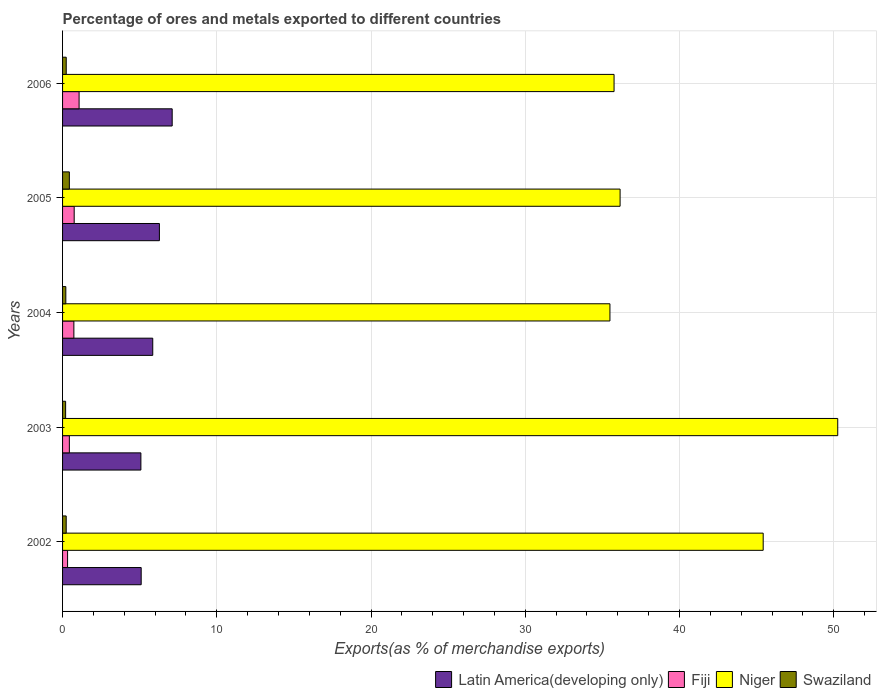How many different coloured bars are there?
Give a very brief answer. 4. Are the number of bars on each tick of the Y-axis equal?
Offer a very short reply. Yes. How many bars are there on the 4th tick from the top?
Provide a succinct answer. 4. How many bars are there on the 3rd tick from the bottom?
Keep it short and to the point. 4. In how many cases, is the number of bars for a given year not equal to the number of legend labels?
Offer a terse response. 0. What is the percentage of exports to different countries in Fiji in 2002?
Keep it short and to the point. 0.33. Across all years, what is the maximum percentage of exports to different countries in Swaziland?
Keep it short and to the point. 0.44. Across all years, what is the minimum percentage of exports to different countries in Latin America(developing only)?
Make the answer very short. 5.08. In which year was the percentage of exports to different countries in Fiji maximum?
Keep it short and to the point. 2006. What is the total percentage of exports to different countries in Latin America(developing only) in the graph?
Ensure brevity in your answer.  29.41. What is the difference between the percentage of exports to different countries in Latin America(developing only) in 2004 and that in 2006?
Provide a succinct answer. -1.26. What is the difference between the percentage of exports to different countries in Fiji in 2006 and the percentage of exports to different countries in Niger in 2002?
Offer a terse response. -44.35. What is the average percentage of exports to different countries in Latin America(developing only) per year?
Keep it short and to the point. 5.88. In the year 2006, what is the difference between the percentage of exports to different countries in Latin America(developing only) and percentage of exports to different countries in Fiji?
Offer a terse response. 6.04. What is the ratio of the percentage of exports to different countries in Latin America(developing only) in 2004 to that in 2005?
Your answer should be very brief. 0.93. What is the difference between the highest and the second highest percentage of exports to different countries in Fiji?
Offer a terse response. 0.32. What is the difference between the highest and the lowest percentage of exports to different countries in Latin America(developing only)?
Give a very brief answer. 2.03. In how many years, is the percentage of exports to different countries in Niger greater than the average percentage of exports to different countries in Niger taken over all years?
Provide a short and direct response. 2. Is it the case that in every year, the sum of the percentage of exports to different countries in Latin America(developing only) and percentage of exports to different countries in Niger is greater than the sum of percentage of exports to different countries in Fiji and percentage of exports to different countries in Swaziland?
Your response must be concise. Yes. What does the 3rd bar from the top in 2002 represents?
Offer a very short reply. Fiji. What does the 2nd bar from the bottom in 2004 represents?
Your answer should be compact. Fiji. Is it the case that in every year, the sum of the percentage of exports to different countries in Swaziland and percentage of exports to different countries in Fiji is greater than the percentage of exports to different countries in Niger?
Keep it short and to the point. No. How many bars are there?
Keep it short and to the point. 20. Are all the bars in the graph horizontal?
Provide a succinct answer. Yes. How many years are there in the graph?
Your answer should be compact. 5. Are the values on the major ticks of X-axis written in scientific E-notation?
Ensure brevity in your answer.  No. How are the legend labels stacked?
Give a very brief answer. Horizontal. What is the title of the graph?
Offer a very short reply. Percentage of ores and metals exported to different countries. Does "Low income" appear as one of the legend labels in the graph?
Provide a succinct answer. No. What is the label or title of the X-axis?
Your answer should be compact. Exports(as % of merchandise exports). What is the label or title of the Y-axis?
Make the answer very short. Years. What is the Exports(as % of merchandise exports) in Latin America(developing only) in 2002?
Your response must be concise. 5.1. What is the Exports(as % of merchandise exports) of Fiji in 2002?
Your answer should be compact. 0.33. What is the Exports(as % of merchandise exports) in Niger in 2002?
Provide a succinct answer. 45.42. What is the Exports(as % of merchandise exports) in Swaziland in 2002?
Your response must be concise. 0.24. What is the Exports(as % of merchandise exports) of Latin America(developing only) in 2003?
Offer a very short reply. 5.08. What is the Exports(as % of merchandise exports) in Fiji in 2003?
Your response must be concise. 0.44. What is the Exports(as % of merchandise exports) in Niger in 2003?
Provide a short and direct response. 50.26. What is the Exports(as % of merchandise exports) in Swaziland in 2003?
Provide a short and direct response. 0.2. What is the Exports(as % of merchandise exports) in Latin America(developing only) in 2004?
Make the answer very short. 5.85. What is the Exports(as % of merchandise exports) of Fiji in 2004?
Give a very brief answer. 0.73. What is the Exports(as % of merchandise exports) in Niger in 2004?
Your answer should be compact. 35.49. What is the Exports(as % of merchandise exports) in Swaziland in 2004?
Your answer should be compact. 0.21. What is the Exports(as % of merchandise exports) in Latin America(developing only) in 2005?
Provide a short and direct response. 6.28. What is the Exports(as % of merchandise exports) of Fiji in 2005?
Keep it short and to the point. 0.75. What is the Exports(as % of merchandise exports) of Niger in 2005?
Offer a terse response. 36.15. What is the Exports(as % of merchandise exports) in Swaziland in 2005?
Your answer should be compact. 0.44. What is the Exports(as % of merchandise exports) in Latin America(developing only) in 2006?
Provide a succinct answer. 7.11. What is the Exports(as % of merchandise exports) in Fiji in 2006?
Your response must be concise. 1.07. What is the Exports(as % of merchandise exports) in Niger in 2006?
Make the answer very short. 35.76. What is the Exports(as % of merchandise exports) of Swaziland in 2006?
Make the answer very short. 0.24. Across all years, what is the maximum Exports(as % of merchandise exports) in Latin America(developing only)?
Give a very brief answer. 7.11. Across all years, what is the maximum Exports(as % of merchandise exports) in Fiji?
Keep it short and to the point. 1.07. Across all years, what is the maximum Exports(as % of merchandise exports) of Niger?
Make the answer very short. 50.26. Across all years, what is the maximum Exports(as % of merchandise exports) of Swaziland?
Offer a very short reply. 0.44. Across all years, what is the minimum Exports(as % of merchandise exports) in Latin America(developing only)?
Keep it short and to the point. 5.08. Across all years, what is the minimum Exports(as % of merchandise exports) in Fiji?
Your response must be concise. 0.33. Across all years, what is the minimum Exports(as % of merchandise exports) in Niger?
Give a very brief answer. 35.49. Across all years, what is the minimum Exports(as % of merchandise exports) of Swaziland?
Your answer should be very brief. 0.2. What is the total Exports(as % of merchandise exports) of Latin America(developing only) in the graph?
Make the answer very short. 29.41. What is the total Exports(as % of merchandise exports) in Fiji in the graph?
Offer a terse response. 3.32. What is the total Exports(as % of merchandise exports) of Niger in the graph?
Provide a succinct answer. 203.07. What is the total Exports(as % of merchandise exports) in Swaziland in the graph?
Provide a short and direct response. 1.33. What is the difference between the Exports(as % of merchandise exports) in Latin America(developing only) in 2002 and that in 2003?
Make the answer very short. 0.02. What is the difference between the Exports(as % of merchandise exports) in Fiji in 2002 and that in 2003?
Offer a very short reply. -0.11. What is the difference between the Exports(as % of merchandise exports) of Niger in 2002 and that in 2003?
Give a very brief answer. -4.83. What is the difference between the Exports(as % of merchandise exports) of Swaziland in 2002 and that in 2003?
Offer a terse response. 0.04. What is the difference between the Exports(as % of merchandise exports) in Latin America(developing only) in 2002 and that in 2004?
Provide a short and direct response. -0.75. What is the difference between the Exports(as % of merchandise exports) in Fiji in 2002 and that in 2004?
Offer a very short reply. -0.41. What is the difference between the Exports(as % of merchandise exports) of Niger in 2002 and that in 2004?
Ensure brevity in your answer.  9.94. What is the difference between the Exports(as % of merchandise exports) in Swaziland in 2002 and that in 2004?
Offer a very short reply. 0.02. What is the difference between the Exports(as % of merchandise exports) in Latin America(developing only) in 2002 and that in 2005?
Offer a terse response. -1.18. What is the difference between the Exports(as % of merchandise exports) of Fiji in 2002 and that in 2005?
Your answer should be very brief. -0.43. What is the difference between the Exports(as % of merchandise exports) of Niger in 2002 and that in 2005?
Provide a succinct answer. 9.28. What is the difference between the Exports(as % of merchandise exports) of Swaziland in 2002 and that in 2005?
Provide a succinct answer. -0.21. What is the difference between the Exports(as % of merchandise exports) of Latin America(developing only) in 2002 and that in 2006?
Provide a succinct answer. -2.01. What is the difference between the Exports(as % of merchandise exports) of Fiji in 2002 and that in 2006?
Provide a short and direct response. -0.75. What is the difference between the Exports(as % of merchandise exports) in Niger in 2002 and that in 2006?
Ensure brevity in your answer.  9.67. What is the difference between the Exports(as % of merchandise exports) of Swaziland in 2002 and that in 2006?
Your answer should be compact. -0. What is the difference between the Exports(as % of merchandise exports) in Latin America(developing only) in 2003 and that in 2004?
Ensure brevity in your answer.  -0.77. What is the difference between the Exports(as % of merchandise exports) of Fiji in 2003 and that in 2004?
Give a very brief answer. -0.29. What is the difference between the Exports(as % of merchandise exports) in Niger in 2003 and that in 2004?
Provide a short and direct response. 14.77. What is the difference between the Exports(as % of merchandise exports) of Swaziland in 2003 and that in 2004?
Offer a very short reply. -0.01. What is the difference between the Exports(as % of merchandise exports) in Latin America(developing only) in 2003 and that in 2005?
Your response must be concise. -1.2. What is the difference between the Exports(as % of merchandise exports) in Fiji in 2003 and that in 2005?
Ensure brevity in your answer.  -0.31. What is the difference between the Exports(as % of merchandise exports) of Niger in 2003 and that in 2005?
Make the answer very short. 14.11. What is the difference between the Exports(as % of merchandise exports) of Swaziland in 2003 and that in 2005?
Offer a terse response. -0.24. What is the difference between the Exports(as % of merchandise exports) of Latin America(developing only) in 2003 and that in 2006?
Make the answer very short. -2.03. What is the difference between the Exports(as % of merchandise exports) in Fiji in 2003 and that in 2006?
Your answer should be compact. -0.63. What is the difference between the Exports(as % of merchandise exports) of Niger in 2003 and that in 2006?
Offer a terse response. 14.5. What is the difference between the Exports(as % of merchandise exports) of Swaziland in 2003 and that in 2006?
Your answer should be compact. -0.04. What is the difference between the Exports(as % of merchandise exports) in Latin America(developing only) in 2004 and that in 2005?
Your response must be concise. -0.43. What is the difference between the Exports(as % of merchandise exports) of Fiji in 2004 and that in 2005?
Provide a succinct answer. -0.02. What is the difference between the Exports(as % of merchandise exports) of Niger in 2004 and that in 2005?
Provide a short and direct response. -0.66. What is the difference between the Exports(as % of merchandise exports) of Swaziland in 2004 and that in 2005?
Ensure brevity in your answer.  -0.23. What is the difference between the Exports(as % of merchandise exports) in Latin America(developing only) in 2004 and that in 2006?
Provide a succinct answer. -1.26. What is the difference between the Exports(as % of merchandise exports) in Fiji in 2004 and that in 2006?
Give a very brief answer. -0.34. What is the difference between the Exports(as % of merchandise exports) of Niger in 2004 and that in 2006?
Give a very brief answer. -0.27. What is the difference between the Exports(as % of merchandise exports) of Swaziland in 2004 and that in 2006?
Give a very brief answer. -0.03. What is the difference between the Exports(as % of merchandise exports) in Latin America(developing only) in 2005 and that in 2006?
Provide a short and direct response. -0.83. What is the difference between the Exports(as % of merchandise exports) in Fiji in 2005 and that in 2006?
Provide a succinct answer. -0.32. What is the difference between the Exports(as % of merchandise exports) of Niger in 2005 and that in 2006?
Your answer should be very brief. 0.39. What is the difference between the Exports(as % of merchandise exports) of Swaziland in 2005 and that in 2006?
Provide a succinct answer. 0.2. What is the difference between the Exports(as % of merchandise exports) in Latin America(developing only) in 2002 and the Exports(as % of merchandise exports) in Fiji in 2003?
Make the answer very short. 4.66. What is the difference between the Exports(as % of merchandise exports) of Latin America(developing only) in 2002 and the Exports(as % of merchandise exports) of Niger in 2003?
Offer a very short reply. -45.16. What is the difference between the Exports(as % of merchandise exports) in Latin America(developing only) in 2002 and the Exports(as % of merchandise exports) in Swaziland in 2003?
Offer a terse response. 4.9. What is the difference between the Exports(as % of merchandise exports) in Fiji in 2002 and the Exports(as % of merchandise exports) in Niger in 2003?
Give a very brief answer. -49.93. What is the difference between the Exports(as % of merchandise exports) of Fiji in 2002 and the Exports(as % of merchandise exports) of Swaziland in 2003?
Give a very brief answer. 0.13. What is the difference between the Exports(as % of merchandise exports) of Niger in 2002 and the Exports(as % of merchandise exports) of Swaziland in 2003?
Give a very brief answer. 45.23. What is the difference between the Exports(as % of merchandise exports) of Latin America(developing only) in 2002 and the Exports(as % of merchandise exports) of Fiji in 2004?
Provide a short and direct response. 4.36. What is the difference between the Exports(as % of merchandise exports) of Latin America(developing only) in 2002 and the Exports(as % of merchandise exports) of Niger in 2004?
Offer a very short reply. -30.39. What is the difference between the Exports(as % of merchandise exports) in Latin America(developing only) in 2002 and the Exports(as % of merchandise exports) in Swaziland in 2004?
Provide a succinct answer. 4.89. What is the difference between the Exports(as % of merchandise exports) of Fiji in 2002 and the Exports(as % of merchandise exports) of Niger in 2004?
Offer a terse response. -35.16. What is the difference between the Exports(as % of merchandise exports) of Fiji in 2002 and the Exports(as % of merchandise exports) of Swaziland in 2004?
Your answer should be very brief. 0.11. What is the difference between the Exports(as % of merchandise exports) in Niger in 2002 and the Exports(as % of merchandise exports) in Swaziland in 2004?
Provide a succinct answer. 45.21. What is the difference between the Exports(as % of merchandise exports) in Latin America(developing only) in 2002 and the Exports(as % of merchandise exports) in Fiji in 2005?
Your answer should be compact. 4.34. What is the difference between the Exports(as % of merchandise exports) in Latin America(developing only) in 2002 and the Exports(as % of merchandise exports) in Niger in 2005?
Your answer should be very brief. -31.05. What is the difference between the Exports(as % of merchandise exports) of Latin America(developing only) in 2002 and the Exports(as % of merchandise exports) of Swaziland in 2005?
Keep it short and to the point. 4.66. What is the difference between the Exports(as % of merchandise exports) in Fiji in 2002 and the Exports(as % of merchandise exports) in Niger in 2005?
Provide a short and direct response. -35.82. What is the difference between the Exports(as % of merchandise exports) of Fiji in 2002 and the Exports(as % of merchandise exports) of Swaziland in 2005?
Keep it short and to the point. -0.12. What is the difference between the Exports(as % of merchandise exports) of Niger in 2002 and the Exports(as % of merchandise exports) of Swaziland in 2005?
Provide a succinct answer. 44.98. What is the difference between the Exports(as % of merchandise exports) of Latin America(developing only) in 2002 and the Exports(as % of merchandise exports) of Fiji in 2006?
Your response must be concise. 4.03. What is the difference between the Exports(as % of merchandise exports) in Latin America(developing only) in 2002 and the Exports(as % of merchandise exports) in Niger in 2006?
Make the answer very short. -30.66. What is the difference between the Exports(as % of merchandise exports) in Latin America(developing only) in 2002 and the Exports(as % of merchandise exports) in Swaziland in 2006?
Offer a very short reply. 4.86. What is the difference between the Exports(as % of merchandise exports) of Fiji in 2002 and the Exports(as % of merchandise exports) of Niger in 2006?
Keep it short and to the point. -35.43. What is the difference between the Exports(as % of merchandise exports) of Fiji in 2002 and the Exports(as % of merchandise exports) of Swaziland in 2006?
Give a very brief answer. 0.09. What is the difference between the Exports(as % of merchandise exports) of Niger in 2002 and the Exports(as % of merchandise exports) of Swaziland in 2006?
Offer a terse response. 45.19. What is the difference between the Exports(as % of merchandise exports) of Latin America(developing only) in 2003 and the Exports(as % of merchandise exports) of Fiji in 2004?
Give a very brief answer. 4.35. What is the difference between the Exports(as % of merchandise exports) of Latin America(developing only) in 2003 and the Exports(as % of merchandise exports) of Niger in 2004?
Your answer should be compact. -30.41. What is the difference between the Exports(as % of merchandise exports) of Latin America(developing only) in 2003 and the Exports(as % of merchandise exports) of Swaziland in 2004?
Offer a terse response. 4.87. What is the difference between the Exports(as % of merchandise exports) of Fiji in 2003 and the Exports(as % of merchandise exports) of Niger in 2004?
Your answer should be very brief. -35.05. What is the difference between the Exports(as % of merchandise exports) in Fiji in 2003 and the Exports(as % of merchandise exports) in Swaziland in 2004?
Provide a short and direct response. 0.23. What is the difference between the Exports(as % of merchandise exports) in Niger in 2003 and the Exports(as % of merchandise exports) in Swaziland in 2004?
Ensure brevity in your answer.  50.05. What is the difference between the Exports(as % of merchandise exports) in Latin America(developing only) in 2003 and the Exports(as % of merchandise exports) in Fiji in 2005?
Offer a terse response. 4.32. What is the difference between the Exports(as % of merchandise exports) in Latin America(developing only) in 2003 and the Exports(as % of merchandise exports) in Niger in 2005?
Provide a succinct answer. -31.07. What is the difference between the Exports(as % of merchandise exports) in Latin America(developing only) in 2003 and the Exports(as % of merchandise exports) in Swaziland in 2005?
Offer a terse response. 4.64. What is the difference between the Exports(as % of merchandise exports) of Fiji in 2003 and the Exports(as % of merchandise exports) of Niger in 2005?
Your response must be concise. -35.71. What is the difference between the Exports(as % of merchandise exports) in Fiji in 2003 and the Exports(as % of merchandise exports) in Swaziland in 2005?
Ensure brevity in your answer.  -0. What is the difference between the Exports(as % of merchandise exports) in Niger in 2003 and the Exports(as % of merchandise exports) in Swaziland in 2005?
Your answer should be compact. 49.82. What is the difference between the Exports(as % of merchandise exports) of Latin America(developing only) in 2003 and the Exports(as % of merchandise exports) of Fiji in 2006?
Your response must be concise. 4.01. What is the difference between the Exports(as % of merchandise exports) of Latin America(developing only) in 2003 and the Exports(as % of merchandise exports) of Niger in 2006?
Offer a terse response. -30.68. What is the difference between the Exports(as % of merchandise exports) of Latin America(developing only) in 2003 and the Exports(as % of merchandise exports) of Swaziland in 2006?
Keep it short and to the point. 4.84. What is the difference between the Exports(as % of merchandise exports) of Fiji in 2003 and the Exports(as % of merchandise exports) of Niger in 2006?
Your answer should be very brief. -35.32. What is the difference between the Exports(as % of merchandise exports) of Fiji in 2003 and the Exports(as % of merchandise exports) of Swaziland in 2006?
Your answer should be compact. 0.2. What is the difference between the Exports(as % of merchandise exports) of Niger in 2003 and the Exports(as % of merchandise exports) of Swaziland in 2006?
Your answer should be very brief. 50.02. What is the difference between the Exports(as % of merchandise exports) in Latin America(developing only) in 2004 and the Exports(as % of merchandise exports) in Fiji in 2005?
Offer a very short reply. 5.09. What is the difference between the Exports(as % of merchandise exports) of Latin America(developing only) in 2004 and the Exports(as % of merchandise exports) of Niger in 2005?
Make the answer very short. -30.3. What is the difference between the Exports(as % of merchandise exports) in Latin America(developing only) in 2004 and the Exports(as % of merchandise exports) in Swaziland in 2005?
Ensure brevity in your answer.  5.41. What is the difference between the Exports(as % of merchandise exports) in Fiji in 2004 and the Exports(as % of merchandise exports) in Niger in 2005?
Your answer should be compact. -35.41. What is the difference between the Exports(as % of merchandise exports) in Fiji in 2004 and the Exports(as % of merchandise exports) in Swaziland in 2005?
Your response must be concise. 0.29. What is the difference between the Exports(as % of merchandise exports) in Niger in 2004 and the Exports(as % of merchandise exports) in Swaziland in 2005?
Your answer should be compact. 35.05. What is the difference between the Exports(as % of merchandise exports) in Latin America(developing only) in 2004 and the Exports(as % of merchandise exports) in Fiji in 2006?
Keep it short and to the point. 4.78. What is the difference between the Exports(as % of merchandise exports) of Latin America(developing only) in 2004 and the Exports(as % of merchandise exports) of Niger in 2006?
Give a very brief answer. -29.91. What is the difference between the Exports(as % of merchandise exports) of Latin America(developing only) in 2004 and the Exports(as % of merchandise exports) of Swaziland in 2006?
Provide a succinct answer. 5.61. What is the difference between the Exports(as % of merchandise exports) in Fiji in 2004 and the Exports(as % of merchandise exports) in Niger in 2006?
Make the answer very short. -35.02. What is the difference between the Exports(as % of merchandise exports) of Fiji in 2004 and the Exports(as % of merchandise exports) of Swaziland in 2006?
Offer a very short reply. 0.5. What is the difference between the Exports(as % of merchandise exports) in Niger in 2004 and the Exports(as % of merchandise exports) in Swaziland in 2006?
Keep it short and to the point. 35.25. What is the difference between the Exports(as % of merchandise exports) in Latin America(developing only) in 2005 and the Exports(as % of merchandise exports) in Fiji in 2006?
Your answer should be compact. 5.21. What is the difference between the Exports(as % of merchandise exports) in Latin America(developing only) in 2005 and the Exports(as % of merchandise exports) in Niger in 2006?
Give a very brief answer. -29.48. What is the difference between the Exports(as % of merchandise exports) in Latin America(developing only) in 2005 and the Exports(as % of merchandise exports) in Swaziland in 2006?
Provide a short and direct response. 6.04. What is the difference between the Exports(as % of merchandise exports) of Fiji in 2005 and the Exports(as % of merchandise exports) of Niger in 2006?
Your response must be concise. -35. What is the difference between the Exports(as % of merchandise exports) of Fiji in 2005 and the Exports(as % of merchandise exports) of Swaziland in 2006?
Your answer should be compact. 0.52. What is the difference between the Exports(as % of merchandise exports) in Niger in 2005 and the Exports(as % of merchandise exports) in Swaziland in 2006?
Provide a succinct answer. 35.91. What is the average Exports(as % of merchandise exports) of Latin America(developing only) per year?
Offer a terse response. 5.88. What is the average Exports(as % of merchandise exports) of Fiji per year?
Give a very brief answer. 0.66. What is the average Exports(as % of merchandise exports) in Niger per year?
Offer a very short reply. 40.61. What is the average Exports(as % of merchandise exports) in Swaziland per year?
Your answer should be compact. 0.27. In the year 2002, what is the difference between the Exports(as % of merchandise exports) in Latin America(developing only) and Exports(as % of merchandise exports) in Fiji?
Your answer should be very brief. 4.77. In the year 2002, what is the difference between the Exports(as % of merchandise exports) in Latin America(developing only) and Exports(as % of merchandise exports) in Niger?
Keep it short and to the point. -40.33. In the year 2002, what is the difference between the Exports(as % of merchandise exports) of Latin America(developing only) and Exports(as % of merchandise exports) of Swaziland?
Your response must be concise. 4.86. In the year 2002, what is the difference between the Exports(as % of merchandise exports) of Fiji and Exports(as % of merchandise exports) of Niger?
Give a very brief answer. -45.1. In the year 2002, what is the difference between the Exports(as % of merchandise exports) of Fiji and Exports(as % of merchandise exports) of Swaziland?
Provide a short and direct response. 0.09. In the year 2002, what is the difference between the Exports(as % of merchandise exports) in Niger and Exports(as % of merchandise exports) in Swaziland?
Provide a succinct answer. 45.19. In the year 2003, what is the difference between the Exports(as % of merchandise exports) in Latin America(developing only) and Exports(as % of merchandise exports) in Fiji?
Make the answer very short. 4.64. In the year 2003, what is the difference between the Exports(as % of merchandise exports) in Latin America(developing only) and Exports(as % of merchandise exports) in Niger?
Make the answer very short. -45.18. In the year 2003, what is the difference between the Exports(as % of merchandise exports) in Latin America(developing only) and Exports(as % of merchandise exports) in Swaziland?
Provide a short and direct response. 4.88. In the year 2003, what is the difference between the Exports(as % of merchandise exports) in Fiji and Exports(as % of merchandise exports) in Niger?
Offer a very short reply. -49.82. In the year 2003, what is the difference between the Exports(as % of merchandise exports) of Fiji and Exports(as % of merchandise exports) of Swaziland?
Your answer should be compact. 0.24. In the year 2003, what is the difference between the Exports(as % of merchandise exports) of Niger and Exports(as % of merchandise exports) of Swaziland?
Give a very brief answer. 50.06. In the year 2004, what is the difference between the Exports(as % of merchandise exports) in Latin America(developing only) and Exports(as % of merchandise exports) in Fiji?
Your response must be concise. 5.11. In the year 2004, what is the difference between the Exports(as % of merchandise exports) in Latin America(developing only) and Exports(as % of merchandise exports) in Niger?
Your answer should be compact. -29.64. In the year 2004, what is the difference between the Exports(as % of merchandise exports) of Latin America(developing only) and Exports(as % of merchandise exports) of Swaziland?
Your answer should be very brief. 5.63. In the year 2004, what is the difference between the Exports(as % of merchandise exports) of Fiji and Exports(as % of merchandise exports) of Niger?
Keep it short and to the point. -34.76. In the year 2004, what is the difference between the Exports(as % of merchandise exports) in Fiji and Exports(as % of merchandise exports) in Swaziland?
Give a very brief answer. 0.52. In the year 2004, what is the difference between the Exports(as % of merchandise exports) of Niger and Exports(as % of merchandise exports) of Swaziland?
Provide a succinct answer. 35.28. In the year 2005, what is the difference between the Exports(as % of merchandise exports) of Latin America(developing only) and Exports(as % of merchandise exports) of Fiji?
Your answer should be very brief. 5.52. In the year 2005, what is the difference between the Exports(as % of merchandise exports) in Latin America(developing only) and Exports(as % of merchandise exports) in Niger?
Ensure brevity in your answer.  -29.87. In the year 2005, what is the difference between the Exports(as % of merchandise exports) in Latin America(developing only) and Exports(as % of merchandise exports) in Swaziland?
Make the answer very short. 5.84. In the year 2005, what is the difference between the Exports(as % of merchandise exports) in Fiji and Exports(as % of merchandise exports) in Niger?
Provide a succinct answer. -35.39. In the year 2005, what is the difference between the Exports(as % of merchandise exports) in Fiji and Exports(as % of merchandise exports) in Swaziland?
Keep it short and to the point. 0.31. In the year 2005, what is the difference between the Exports(as % of merchandise exports) of Niger and Exports(as % of merchandise exports) of Swaziland?
Keep it short and to the point. 35.71. In the year 2006, what is the difference between the Exports(as % of merchandise exports) of Latin America(developing only) and Exports(as % of merchandise exports) of Fiji?
Ensure brevity in your answer.  6.04. In the year 2006, what is the difference between the Exports(as % of merchandise exports) of Latin America(developing only) and Exports(as % of merchandise exports) of Niger?
Offer a very short reply. -28.65. In the year 2006, what is the difference between the Exports(as % of merchandise exports) of Latin America(developing only) and Exports(as % of merchandise exports) of Swaziland?
Ensure brevity in your answer.  6.87. In the year 2006, what is the difference between the Exports(as % of merchandise exports) of Fiji and Exports(as % of merchandise exports) of Niger?
Provide a succinct answer. -34.68. In the year 2006, what is the difference between the Exports(as % of merchandise exports) of Fiji and Exports(as % of merchandise exports) of Swaziland?
Provide a succinct answer. 0.83. In the year 2006, what is the difference between the Exports(as % of merchandise exports) of Niger and Exports(as % of merchandise exports) of Swaziland?
Provide a succinct answer. 35.52. What is the ratio of the Exports(as % of merchandise exports) of Fiji in 2002 to that in 2003?
Your response must be concise. 0.74. What is the ratio of the Exports(as % of merchandise exports) in Niger in 2002 to that in 2003?
Provide a short and direct response. 0.9. What is the ratio of the Exports(as % of merchandise exports) in Swaziland in 2002 to that in 2003?
Offer a very short reply. 1.19. What is the ratio of the Exports(as % of merchandise exports) of Latin America(developing only) in 2002 to that in 2004?
Make the answer very short. 0.87. What is the ratio of the Exports(as % of merchandise exports) in Fiji in 2002 to that in 2004?
Give a very brief answer. 0.44. What is the ratio of the Exports(as % of merchandise exports) in Niger in 2002 to that in 2004?
Make the answer very short. 1.28. What is the ratio of the Exports(as % of merchandise exports) in Swaziland in 2002 to that in 2004?
Make the answer very short. 1.11. What is the ratio of the Exports(as % of merchandise exports) in Latin America(developing only) in 2002 to that in 2005?
Offer a very short reply. 0.81. What is the ratio of the Exports(as % of merchandise exports) of Fiji in 2002 to that in 2005?
Give a very brief answer. 0.43. What is the ratio of the Exports(as % of merchandise exports) in Niger in 2002 to that in 2005?
Your response must be concise. 1.26. What is the ratio of the Exports(as % of merchandise exports) in Swaziland in 2002 to that in 2005?
Your answer should be very brief. 0.53. What is the ratio of the Exports(as % of merchandise exports) in Latin America(developing only) in 2002 to that in 2006?
Provide a short and direct response. 0.72. What is the ratio of the Exports(as % of merchandise exports) in Fiji in 2002 to that in 2006?
Offer a terse response. 0.3. What is the ratio of the Exports(as % of merchandise exports) in Niger in 2002 to that in 2006?
Provide a short and direct response. 1.27. What is the ratio of the Exports(as % of merchandise exports) of Swaziland in 2002 to that in 2006?
Make the answer very short. 0.99. What is the ratio of the Exports(as % of merchandise exports) of Latin America(developing only) in 2003 to that in 2004?
Make the answer very short. 0.87. What is the ratio of the Exports(as % of merchandise exports) of Fiji in 2003 to that in 2004?
Your answer should be compact. 0.6. What is the ratio of the Exports(as % of merchandise exports) in Niger in 2003 to that in 2004?
Ensure brevity in your answer.  1.42. What is the ratio of the Exports(as % of merchandise exports) in Swaziland in 2003 to that in 2004?
Keep it short and to the point. 0.94. What is the ratio of the Exports(as % of merchandise exports) in Latin America(developing only) in 2003 to that in 2005?
Ensure brevity in your answer.  0.81. What is the ratio of the Exports(as % of merchandise exports) of Fiji in 2003 to that in 2005?
Provide a succinct answer. 0.58. What is the ratio of the Exports(as % of merchandise exports) of Niger in 2003 to that in 2005?
Offer a very short reply. 1.39. What is the ratio of the Exports(as % of merchandise exports) in Swaziland in 2003 to that in 2005?
Your answer should be very brief. 0.45. What is the ratio of the Exports(as % of merchandise exports) in Latin America(developing only) in 2003 to that in 2006?
Provide a short and direct response. 0.71. What is the ratio of the Exports(as % of merchandise exports) in Fiji in 2003 to that in 2006?
Provide a succinct answer. 0.41. What is the ratio of the Exports(as % of merchandise exports) of Niger in 2003 to that in 2006?
Ensure brevity in your answer.  1.41. What is the ratio of the Exports(as % of merchandise exports) in Swaziland in 2003 to that in 2006?
Ensure brevity in your answer.  0.83. What is the ratio of the Exports(as % of merchandise exports) of Latin America(developing only) in 2004 to that in 2005?
Provide a succinct answer. 0.93. What is the ratio of the Exports(as % of merchandise exports) in Fiji in 2004 to that in 2005?
Make the answer very short. 0.97. What is the ratio of the Exports(as % of merchandise exports) in Niger in 2004 to that in 2005?
Provide a succinct answer. 0.98. What is the ratio of the Exports(as % of merchandise exports) in Swaziland in 2004 to that in 2005?
Offer a very short reply. 0.48. What is the ratio of the Exports(as % of merchandise exports) of Latin America(developing only) in 2004 to that in 2006?
Provide a short and direct response. 0.82. What is the ratio of the Exports(as % of merchandise exports) of Fiji in 2004 to that in 2006?
Offer a terse response. 0.68. What is the ratio of the Exports(as % of merchandise exports) in Swaziland in 2004 to that in 2006?
Offer a very short reply. 0.89. What is the ratio of the Exports(as % of merchandise exports) of Latin America(developing only) in 2005 to that in 2006?
Provide a short and direct response. 0.88. What is the ratio of the Exports(as % of merchandise exports) of Fiji in 2005 to that in 2006?
Offer a terse response. 0.7. What is the ratio of the Exports(as % of merchandise exports) of Niger in 2005 to that in 2006?
Give a very brief answer. 1.01. What is the ratio of the Exports(as % of merchandise exports) of Swaziland in 2005 to that in 2006?
Your response must be concise. 1.85. What is the difference between the highest and the second highest Exports(as % of merchandise exports) of Latin America(developing only)?
Keep it short and to the point. 0.83. What is the difference between the highest and the second highest Exports(as % of merchandise exports) in Fiji?
Your answer should be compact. 0.32. What is the difference between the highest and the second highest Exports(as % of merchandise exports) of Niger?
Make the answer very short. 4.83. What is the difference between the highest and the second highest Exports(as % of merchandise exports) of Swaziland?
Your answer should be very brief. 0.2. What is the difference between the highest and the lowest Exports(as % of merchandise exports) in Latin America(developing only)?
Make the answer very short. 2.03. What is the difference between the highest and the lowest Exports(as % of merchandise exports) in Fiji?
Keep it short and to the point. 0.75. What is the difference between the highest and the lowest Exports(as % of merchandise exports) of Niger?
Provide a succinct answer. 14.77. What is the difference between the highest and the lowest Exports(as % of merchandise exports) of Swaziland?
Your response must be concise. 0.24. 